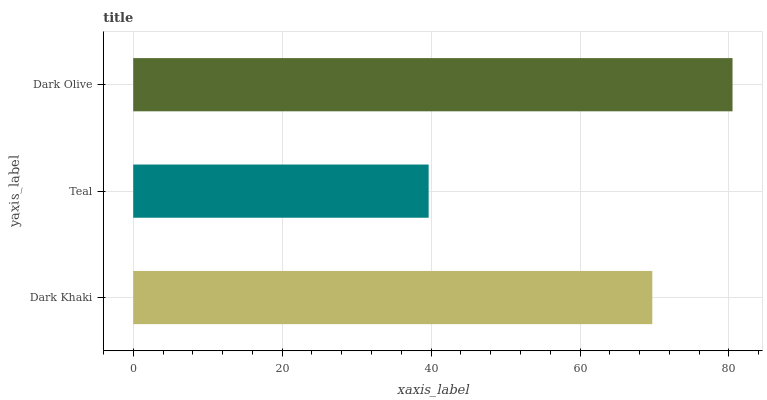Is Teal the minimum?
Answer yes or no. Yes. Is Dark Olive the maximum?
Answer yes or no. Yes. Is Dark Olive the minimum?
Answer yes or no. No. Is Teal the maximum?
Answer yes or no. No. Is Dark Olive greater than Teal?
Answer yes or no. Yes. Is Teal less than Dark Olive?
Answer yes or no. Yes. Is Teal greater than Dark Olive?
Answer yes or no. No. Is Dark Olive less than Teal?
Answer yes or no. No. Is Dark Khaki the high median?
Answer yes or no. Yes. Is Dark Khaki the low median?
Answer yes or no. Yes. Is Dark Olive the high median?
Answer yes or no. No. Is Dark Olive the low median?
Answer yes or no. No. 